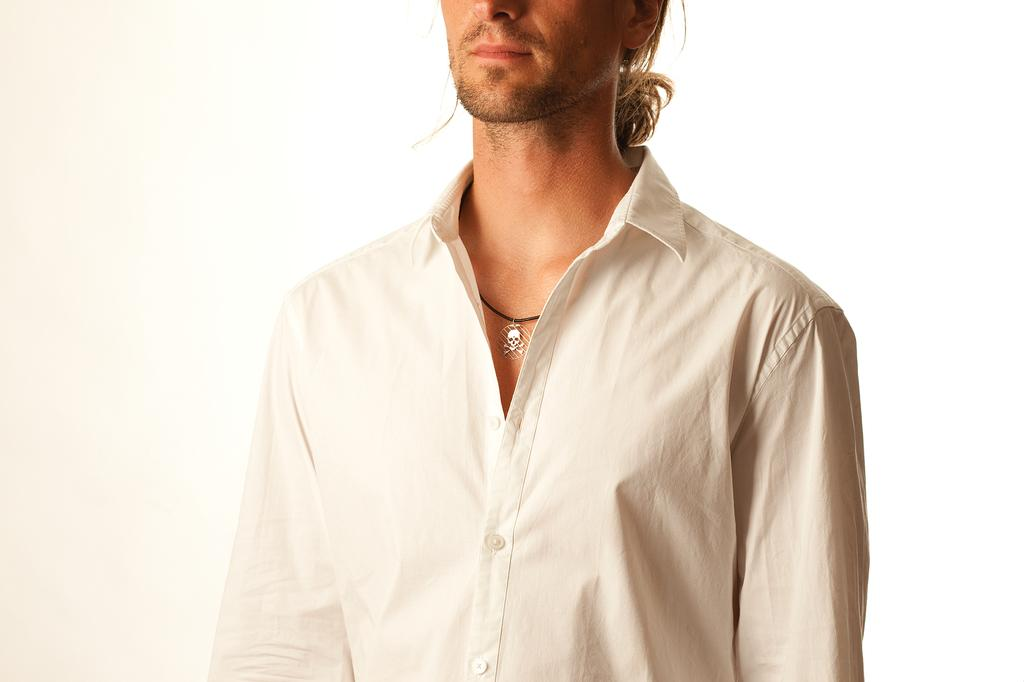Who or what is the main subject in the image? There is a person in the image. What is the person wearing? The person is wearing a white shirt. Is there any accessory or object around the person's neck? There is a wocket in the person's neck (possibly a typo for "watch" or "necklace"). What is the color of the background in the image? The background of the image is white. What letter is the person holding in the image? There is no letter present in the image; the person is wearing a white shirt and has a wocket (possibly a typo for "watch" or "necklace") around their neck. What type of lamp is visible in the image? There is no lamp present in the image; the main subject is a person wearing a white shirt with a wocket (possibly a typo for "watch" or "necklace") around their neck, and the background is white. 